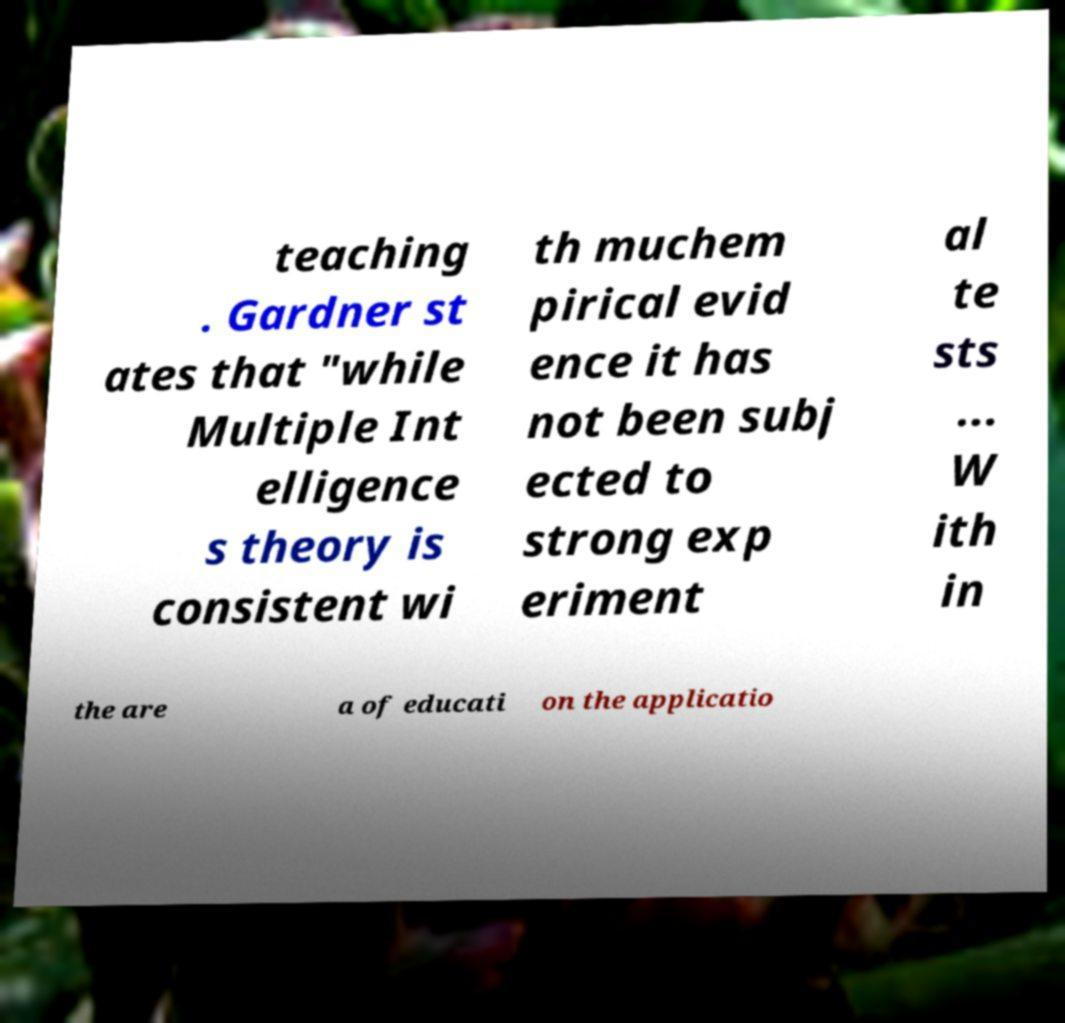For documentation purposes, I need the text within this image transcribed. Could you provide that? teaching . Gardner st ates that "while Multiple Int elligence s theory is consistent wi th muchem pirical evid ence it has not been subj ected to strong exp eriment al te sts ... W ith in the are a of educati on the applicatio 